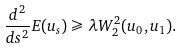<formula> <loc_0><loc_0><loc_500><loc_500>\frac { d ^ { 2 } } { d s ^ { 2 } } E ( u _ { s } ) \geqslant \lambda W _ { 2 } ^ { 2 } ( u _ { 0 } , u _ { 1 } ) .</formula> 